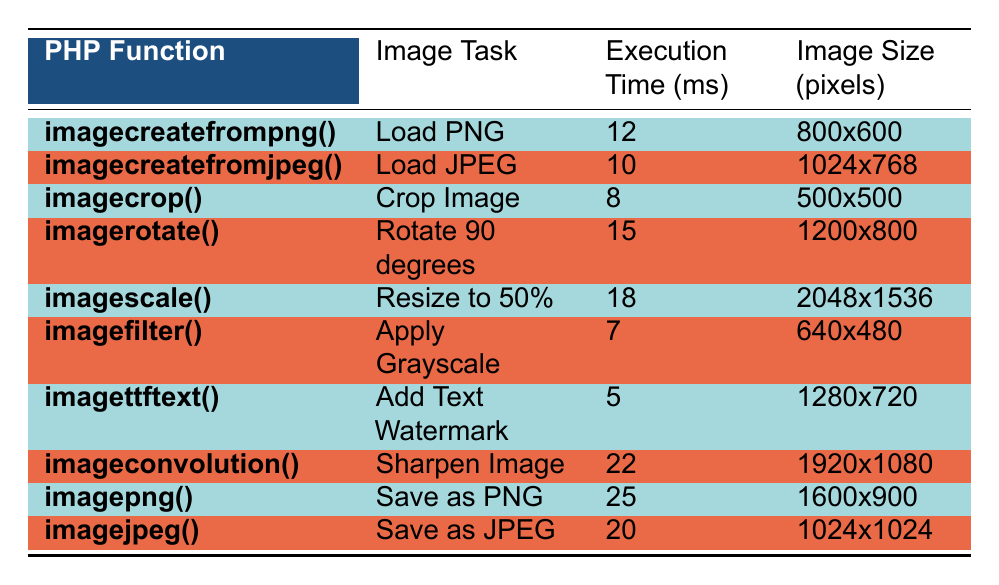What is the execution time for the function imagecreatefromjpeg()? The execution time is listed directly in the column for that function. Looking at the row for imagecreatefromjpeg(), it states the execution time is 10 ms.
Answer: 10 ms Which function takes the longest time to complete? By reviewing each execution time listed, the highest value is found in the row for imagepng(), which indicates an execution time of 25 ms.
Answer: imagepng() What is the total execution time of all image processing tasks? The sum of all execution times is calculated by adding each of the values: 12 + 10 + 8 + 15 + 18 + 7 + 5 + 22 + 25 + 20 =  147 ms.
Answer: 147 ms Is the function imagettftext() faster than the function imagefilter()? Comparing the execution times, imagettftext() has an execution time of 5 ms, while imagefilter() has 7 ms. Since 5 ms < 7 ms, imagettftext() is indeed faster.
Answer: Yes What is the average execution time for saving image tasks? Identifying the functions related to saving images, we have imagepng() and imagejpeg() with execution times of 25 ms and 20 ms respectively. The average is calculated as (25 + 20) / 2 = 22.5 ms.
Answer: 22.5 ms Which image processing task has the smallest image size? Looking at the Image Size column, the smallest size recorded is 500x500 pixels, which corresponds to the imagecrop() task.
Answer: imagecrop() Does any function take less than 10 ms? Checking the execution times, only imagefilter() (7 ms) and imagettftext() (5 ms) fall below the 10 ms mark, proving that there are indeed such functions.
Answer: Yes What is the difference in execution time between the fastest and the slowest function? The fastest function is imagettftext() with 5 ms, and the slowest is imagepng() with 25 ms. The difference is calculated by subtracting: 25 - 5 = 20 ms.
Answer: 20 ms How many functions have execution times above 15 ms? Reviewing the execution times listed, the functions with above 15 ms are imagescale(), imageconvolution(), imagepng(), and imagejpeg(). Counting these gives us 4 functions.
Answer: 4 